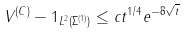<formula> <loc_0><loc_0><loc_500><loc_500>\| V ^ { ( C ) } - 1 \| _ { L ^ { 2 } ( \Sigma ^ { ( 1 ) } ) } \leq c t ^ { 1 / 4 } e ^ { - 8 \sqrt { t } }</formula> 